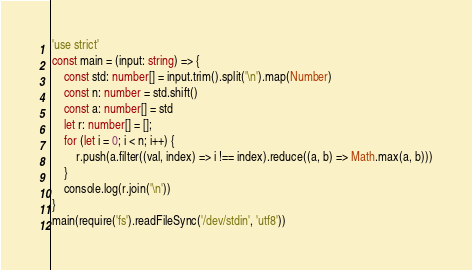<code> <loc_0><loc_0><loc_500><loc_500><_TypeScript_>'use strict'
const main = (input: string) => {
    const std: number[] = input.trim().split('\n').map(Number)
    const n: number = std.shift()
    const a: number[] = std
    let r: number[] = [];
    for (let i = 0; i < n; i++) {
        r.push(a.filter((val, index) => i !== index).reduce((a, b) => Math.max(a, b)))
    }
    console.log(r.join('\n'))
}
main(require('fs').readFileSync('/dev/stdin', 'utf8'))
</code> 